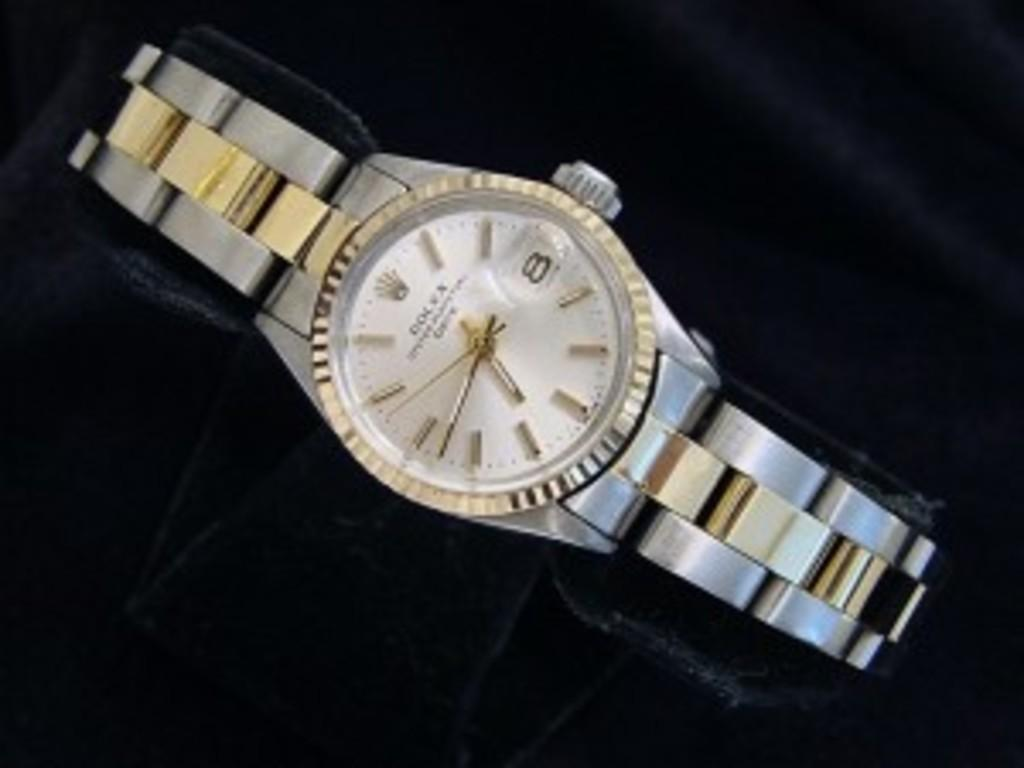What object can be seen in the image? There is a watch in the image. Where is the watch located? The watch is placed on a table. How many spiders are crawling on the window in the image? There are no spiders or windows present in the image; it only features a watch placed on a table. 